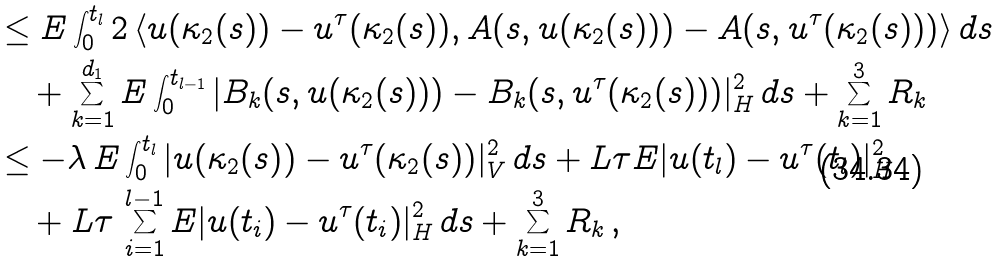<formula> <loc_0><loc_0><loc_500><loc_500>& \leq E \int _ { 0 } ^ { t _ { l } } 2 \left \langle u ( \kappa _ { 2 } ( s ) ) - u ^ { \tau } ( \kappa _ { 2 } ( s ) ) , A ( s , u ( \kappa _ { 2 } ( s ) ) ) - A ( s , u ^ { \tau } ( \kappa _ { 2 } ( s ) ) ) \right \rangle d s \\ & \quad + \sum _ { k = 1 } ^ { d _ { 1 } } E \int _ { 0 } ^ { t _ { l - 1 } } | B _ { k } ( s , u ( \kappa _ { 2 } ( s ) ) ) - B _ { k } ( s , u ^ { \tau } ( \kappa _ { 2 } ( s ) ) ) | _ { H } ^ { 2 } \, d s + \sum _ { k = 1 } ^ { 3 } R _ { k } \\ & \leq - \lambda \, E \int _ { 0 } ^ { t _ { l } } | u ( \kappa _ { 2 } ( s ) ) - u ^ { \tau } ( \kappa _ { 2 } ( s ) ) | _ { V } ^ { 2 } \, d s + L \tau E | u ( t _ { l } ) - u ^ { \tau } ( t _ { l } ) | _ { H } ^ { 2 } \\ & \quad + L \tau \, \sum _ { i = 1 } ^ { l - 1 } E | u ( t _ { i } ) - u ^ { \tau } ( t _ { i } ) | _ { H } ^ { 2 } \, d s + \sum _ { k = 1 } ^ { 3 } R _ { k } \, ,</formula> 